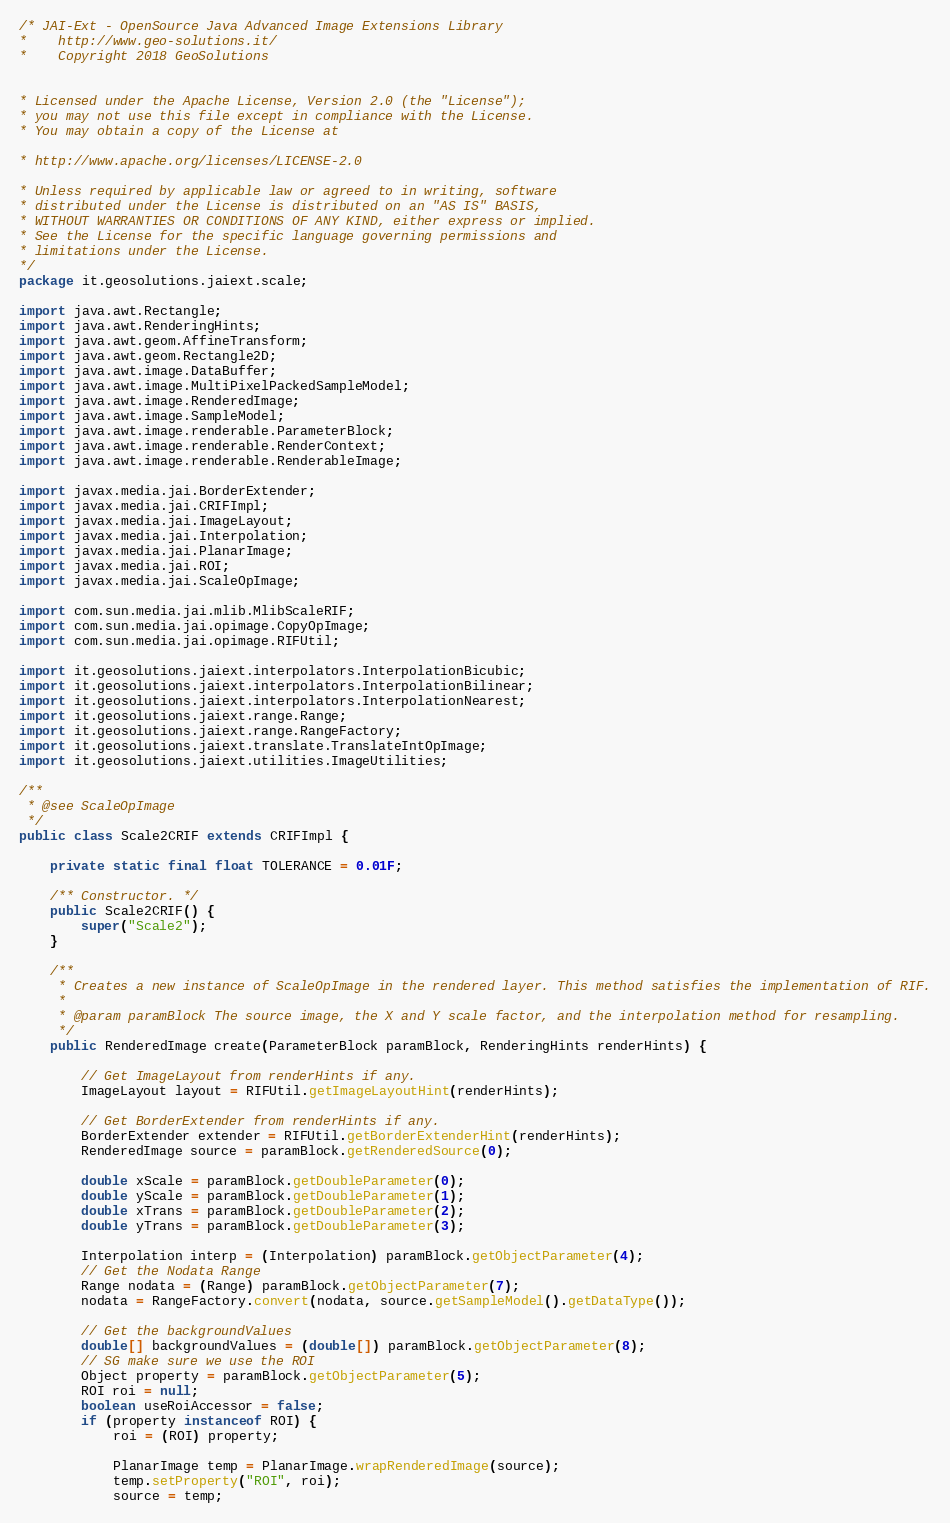<code> <loc_0><loc_0><loc_500><loc_500><_Java_>/* JAI-Ext - OpenSource Java Advanced Image Extensions Library
*    http://www.geo-solutions.it/
*    Copyright 2018 GeoSolutions


* Licensed under the Apache License, Version 2.0 (the "License");
* you may not use this file except in compliance with the License.
* You may obtain a copy of the License at

* http://www.apache.org/licenses/LICENSE-2.0

* Unless required by applicable law or agreed to in writing, software
* distributed under the License is distributed on an "AS IS" BASIS,
* WITHOUT WARRANTIES OR CONDITIONS OF ANY KIND, either express or implied.
* See the License for the specific language governing permissions and
* limitations under the License.
*/
package it.geosolutions.jaiext.scale;

import java.awt.Rectangle;
import java.awt.RenderingHints;
import java.awt.geom.AffineTransform;
import java.awt.geom.Rectangle2D;
import java.awt.image.DataBuffer;
import java.awt.image.MultiPixelPackedSampleModel;
import java.awt.image.RenderedImage;
import java.awt.image.SampleModel;
import java.awt.image.renderable.ParameterBlock;
import java.awt.image.renderable.RenderContext;
import java.awt.image.renderable.RenderableImage;

import javax.media.jai.BorderExtender;
import javax.media.jai.CRIFImpl;
import javax.media.jai.ImageLayout;
import javax.media.jai.Interpolation;
import javax.media.jai.PlanarImage;
import javax.media.jai.ROI;
import javax.media.jai.ScaleOpImage;

import com.sun.media.jai.mlib.MlibScaleRIF;
import com.sun.media.jai.opimage.CopyOpImage;
import com.sun.media.jai.opimage.RIFUtil;

import it.geosolutions.jaiext.interpolators.InterpolationBicubic;
import it.geosolutions.jaiext.interpolators.InterpolationBilinear;
import it.geosolutions.jaiext.interpolators.InterpolationNearest;
import it.geosolutions.jaiext.range.Range;
import it.geosolutions.jaiext.range.RangeFactory;
import it.geosolutions.jaiext.translate.TranslateIntOpImage;
import it.geosolutions.jaiext.utilities.ImageUtilities;

/**
 * @see ScaleOpImage
 */
public class Scale2CRIF extends CRIFImpl {

    private static final float TOLERANCE = 0.01F;

    /** Constructor. */
    public Scale2CRIF() {
        super("Scale2");
    }

    /**
     * Creates a new instance of ScaleOpImage in the rendered layer. This method satisfies the implementation of RIF.
     * 
     * @param paramBlock The source image, the X and Y scale factor, and the interpolation method for resampling.
     */
    public RenderedImage create(ParameterBlock paramBlock, RenderingHints renderHints) {

        // Get ImageLayout from renderHints if any.
        ImageLayout layout = RIFUtil.getImageLayoutHint(renderHints);

        // Get BorderExtender from renderHints if any.
        BorderExtender extender = RIFUtil.getBorderExtenderHint(renderHints);
        RenderedImage source = paramBlock.getRenderedSource(0);

        double xScale = paramBlock.getDoubleParameter(0);
        double yScale = paramBlock.getDoubleParameter(1);
        double xTrans = paramBlock.getDoubleParameter(2);
        double yTrans = paramBlock.getDoubleParameter(3);

        Interpolation interp = (Interpolation) paramBlock.getObjectParameter(4);
        // Get the Nodata Range
        Range nodata = (Range) paramBlock.getObjectParameter(7);
        nodata = RangeFactory.convert(nodata, source.getSampleModel().getDataType());

        // Get the backgroundValues
        double[] backgroundValues = (double[]) paramBlock.getObjectParameter(8);
        // SG make sure we use the ROI
        Object property = paramBlock.getObjectParameter(5);
        ROI roi = null;
        boolean useRoiAccessor = false;
        if (property instanceof ROI) {
            roi = (ROI) property;

            PlanarImage temp = PlanarImage.wrapRenderedImage(source);
            temp.setProperty("ROI", roi);
            source = temp;</code> 